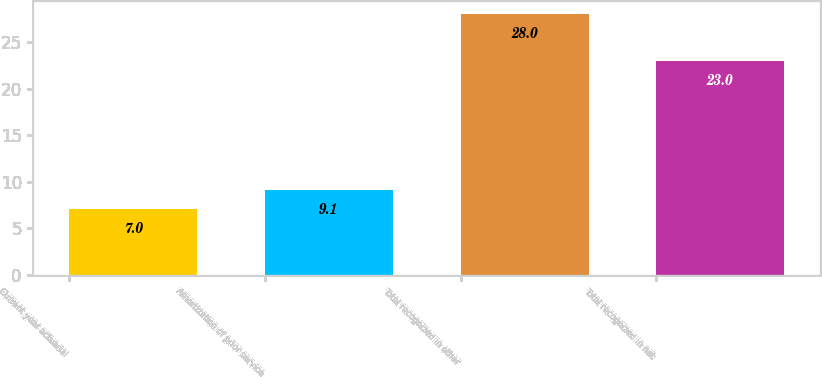Convert chart. <chart><loc_0><loc_0><loc_500><loc_500><bar_chart><fcel>Current year actuarial<fcel>Amortization of prior service<fcel>Total recognized in other<fcel>Total recognized in net<nl><fcel>7<fcel>9.1<fcel>28<fcel>23<nl></chart> 